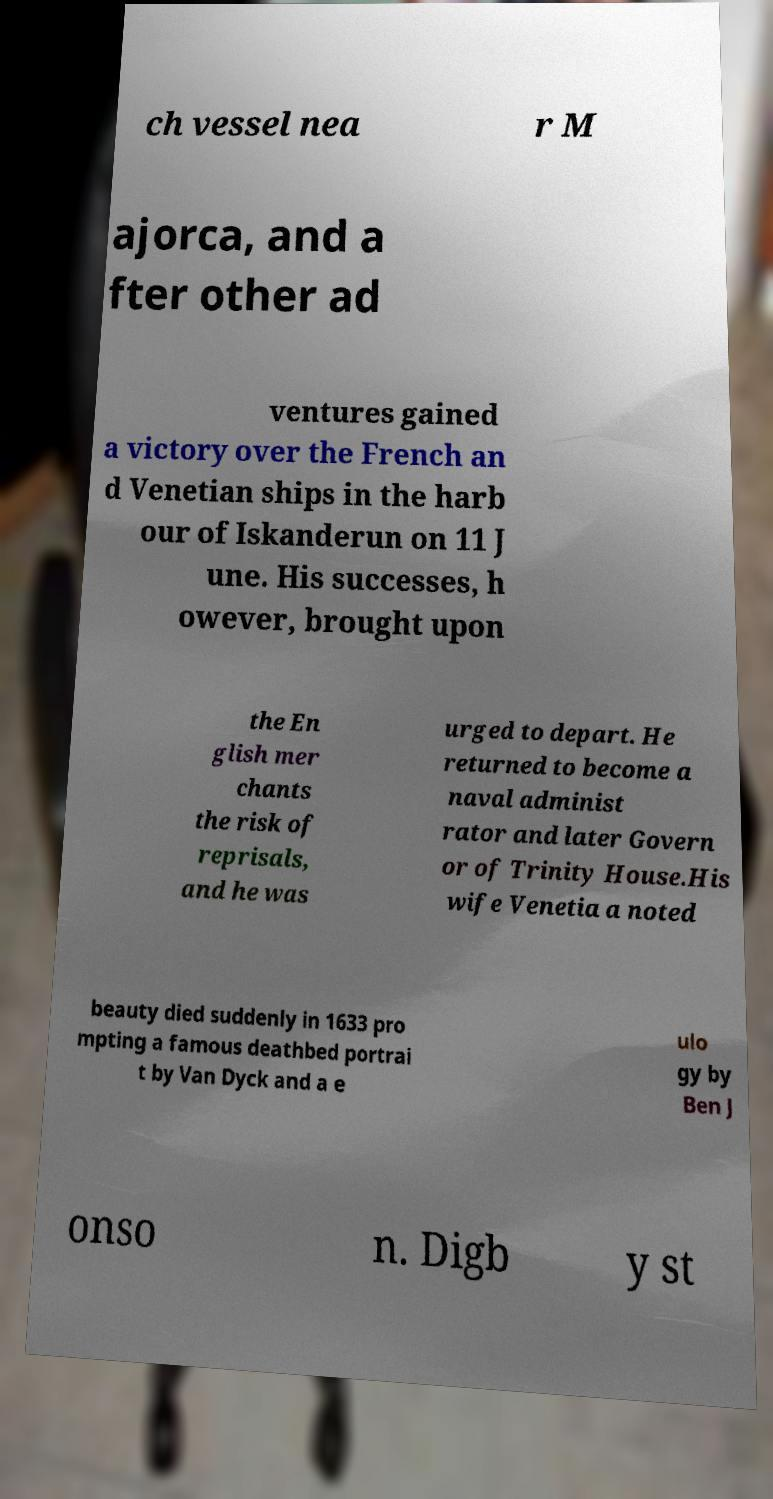I need the written content from this picture converted into text. Can you do that? ch vessel nea r M ajorca, and a fter other ad ventures gained a victory over the French an d Venetian ships in the harb our of Iskanderun on 11 J une. His successes, h owever, brought upon the En glish mer chants the risk of reprisals, and he was urged to depart. He returned to become a naval administ rator and later Govern or of Trinity House.His wife Venetia a noted beauty died suddenly in 1633 pro mpting a famous deathbed portrai t by Van Dyck and a e ulo gy by Ben J onso n. Digb y st 